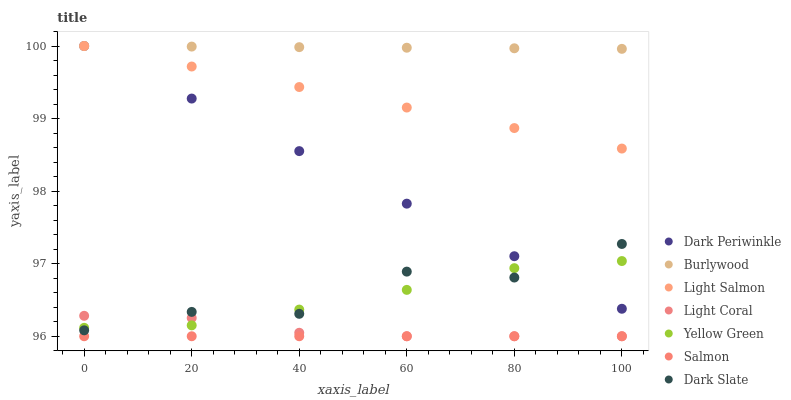Does Salmon have the minimum area under the curve?
Answer yes or no. Yes. Does Burlywood have the maximum area under the curve?
Answer yes or no. Yes. Does Yellow Green have the minimum area under the curve?
Answer yes or no. No. Does Yellow Green have the maximum area under the curve?
Answer yes or no. No. Is Salmon the smoothest?
Answer yes or no. Yes. Is Dark Slate the roughest?
Answer yes or no. Yes. Is Yellow Green the smoothest?
Answer yes or no. No. Is Yellow Green the roughest?
Answer yes or no. No. Does Salmon have the lowest value?
Answer yes or no. Yes. Does Yellow Green have the lowest value?
Answer yes or no. No. Does Dark Periwinkle have the highest value?
Answer yes or no. Yes. Does Yellow Green have the highest value?
Answer yes or no. No. Is Salmon less than Yellow Green?
Answer yes or no. Yes. Is Dark Periwinkle greater than Light Coral?
Answer yes or no. Yes. Does Dark Periwinkle intersect Burlywood?
Answer yes or no. Yes. Is Dark Periwinkle less than Burlywood?
Answer yes or no. No. Is Dark Periwinkle greater than Burlywood?
Answer yes or no. No. Does Salmon intersect Yellow Green?
Answer yes or no. No. 